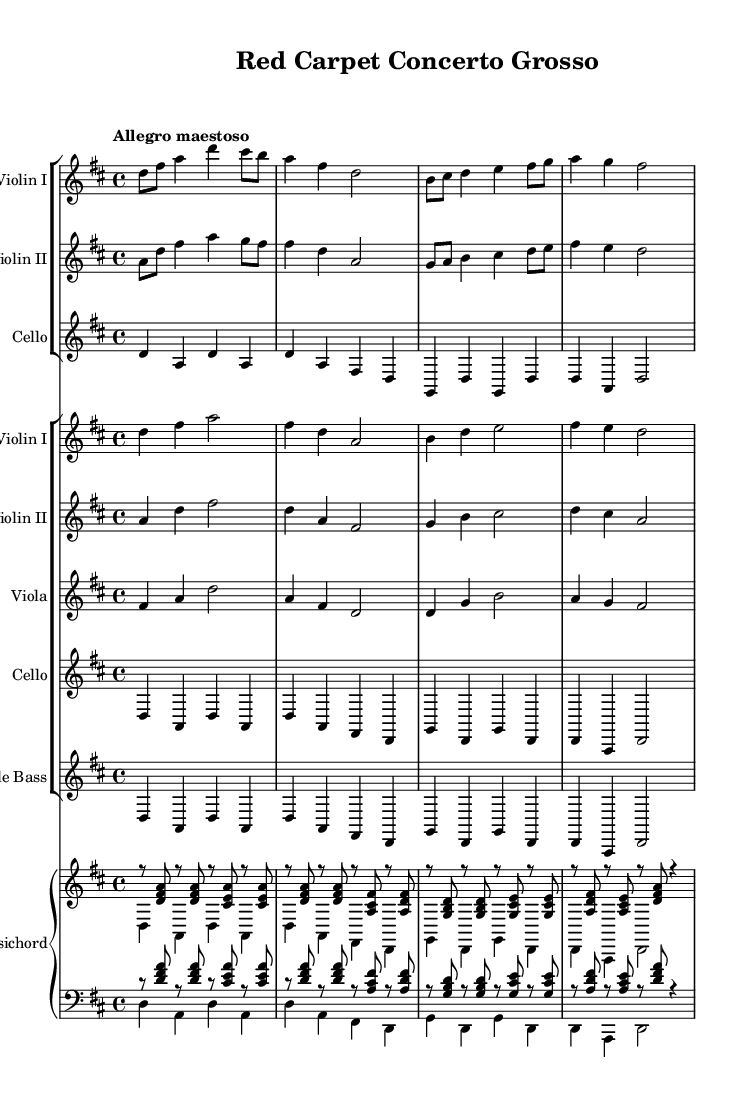What is the key signature of this music? The key signature indicates the piece is in D major, which has two sharps (F# and C#). This can be determined by looking at the key signature indicated at the beginning of the score.
Answer: D major What is the time signature of this music? The time signature is 4/4, which is shown at the beginning of the score. This means there are four beats in a measure and the quarter note receives one beat.
Answer: 4/4 What tempo marking is indicated for this piece? The tempo marking "Allegro maestoso" suggests a fast and majestic pace. This is noted at the beginning of the score and implies a lively character.
Answer: Allegro maestoso How many different instruments are featured in the concerto? The score includes six different instrumental parts: Violin I, Violin II, Cello, Viola, Double Bass, and Harpsichord, indicating a rich texture typical of a Concerto Grosso.
Answer: Six What is the structure of the concertino section? The concertino section consists of one solo line for each instrument: two violins and a cello, making it distinct compared to the ripieno. This can be inferred from how the solo lines are featured separately from the accompaniment in the rest of the score.
Answer: Three Which instrument plays the role of accompaniment in this concerto? The harpsichord serves as the continuo instrument, providing harmonic support and reinforcing the texture of the ensemble. This is evident where the harpsichord is notated alongside the ensemble parts.
Answer: Harpsichord What musical period do these pieces belong to? The score is representative of the Baroque period, characterized by the concerto grosso format, the utilization of contrasting groups of instruments, and the harmonic style prevalent during this time. This classification can be deduced from the style and form of the music presented.
Answer: Baroque 